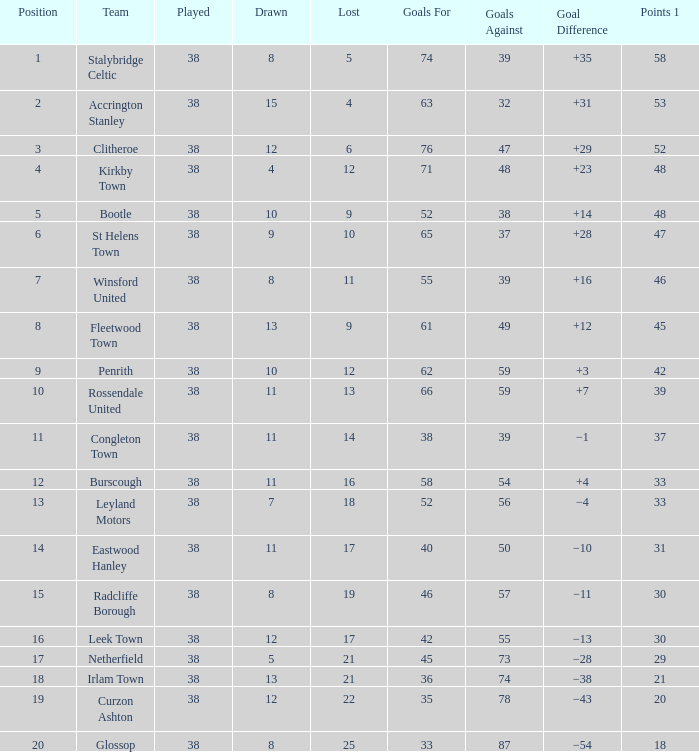What is the combined number drawn with goals against below 55, and a count of 14 losses? 1.0. Could you parse the entire table? {'header': ['Position', 'Team', 'Played', 'Drawn', 'Lost', 'Goals For', 'Goals Against', 'Goal Difference', 'Points 1'], 'rows': [['1', 'Stalybridge Celtic', '38', '8', '5', '74', '39', '+35', '58'], ['2', 'Accrington Stanley', '38', '15', '4', '63', '32', '+31', '53'], ['3', 'Clitheroe', '38', '12', '6', '76', '47', '+29', '52'], ['4', 'Kirkby Town', '38', '4', '12', '71', '48', '+23', '48'], ['5', 'Bootle', '38', '10', '9', '52', '38', '+14', '48'], ['6', 'St Helens Town', '38', '9', '10', '65', '37', '+28', '47'], ['7', 'Winsford United', '38', '8', '11', '55', '39', '+16', '46'], ['8', 'Fleetwood Town', '38', '13', '9', '61', '49', '+12', '45'], ['9', 'Penrith', '38', '10', '12', '62', '59', '+3', '42'], ['10', 'Rossendale United', '38', '11', '13', '66', '59', '+7', '39'], ['11', 'Congleton Town', '38', '11', '14', '38', '39', '−1', '37'], ['12', 'Burscough', '38', '11', '16', '58', '54', '+4', '33'], ['13', 'Leyland Motors', '38', '7', '18', '52', '56', '−4', '33'], ['14', 'Eastwood Hanley', '38', '11', '17', '40', '50', '−10', '31'], ['15', 'Radcliffe Borough', '38', '8', '19', '46', '57', '−11', '30'], ['16', 'Leek Town', '38', '12', '17', '42', '55', '−13', '30'], ['17', 'Netherfield', '38', '5', '21', '45', '73', '−28', '29'], ['18', 'Irlam Town', '38', '13', '21', '36', '74', '−38', '21'], ['19', 'Curzon Ashton', '38', '12', '22', '35', '78', '−43', '20'], ['20', 'Glossop', '38', '8', '25', '33', '87', '−54', '18']]} 